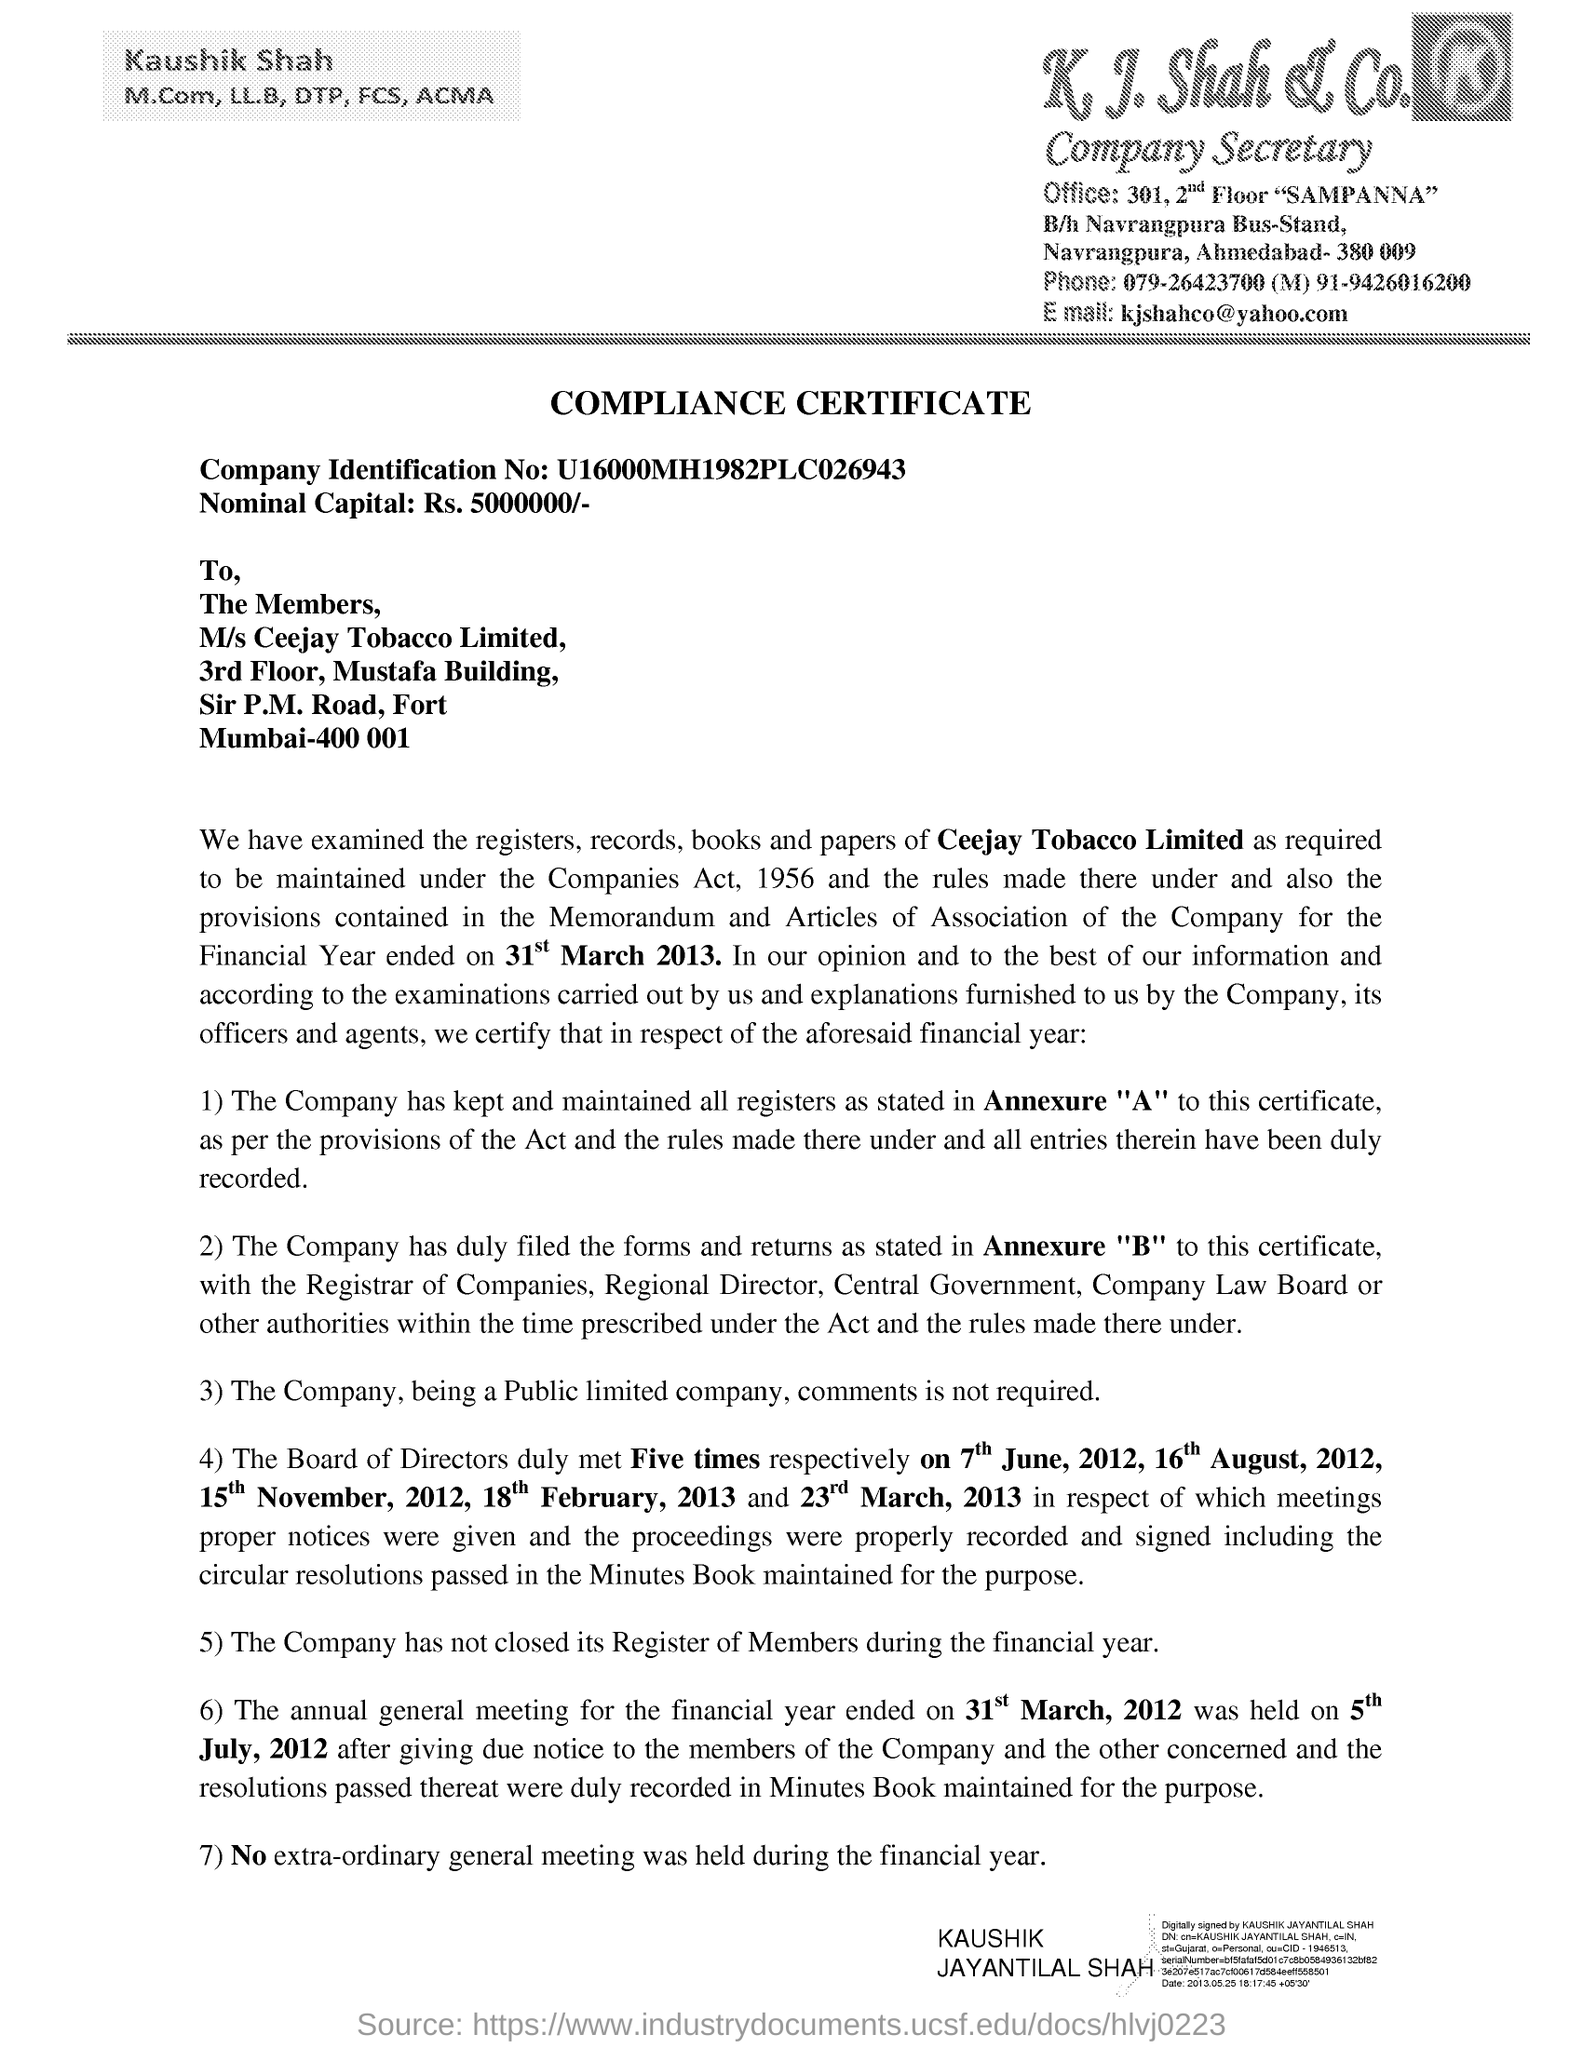What is the Company Identification No given in the document? The Company Identification Number given in the document is U16000MH1982PLC026943. This unique identifier is used to officially register Ceejay Tobacco Limited with the Registrar of Companies in India, ensuring its legal corporate identity. 